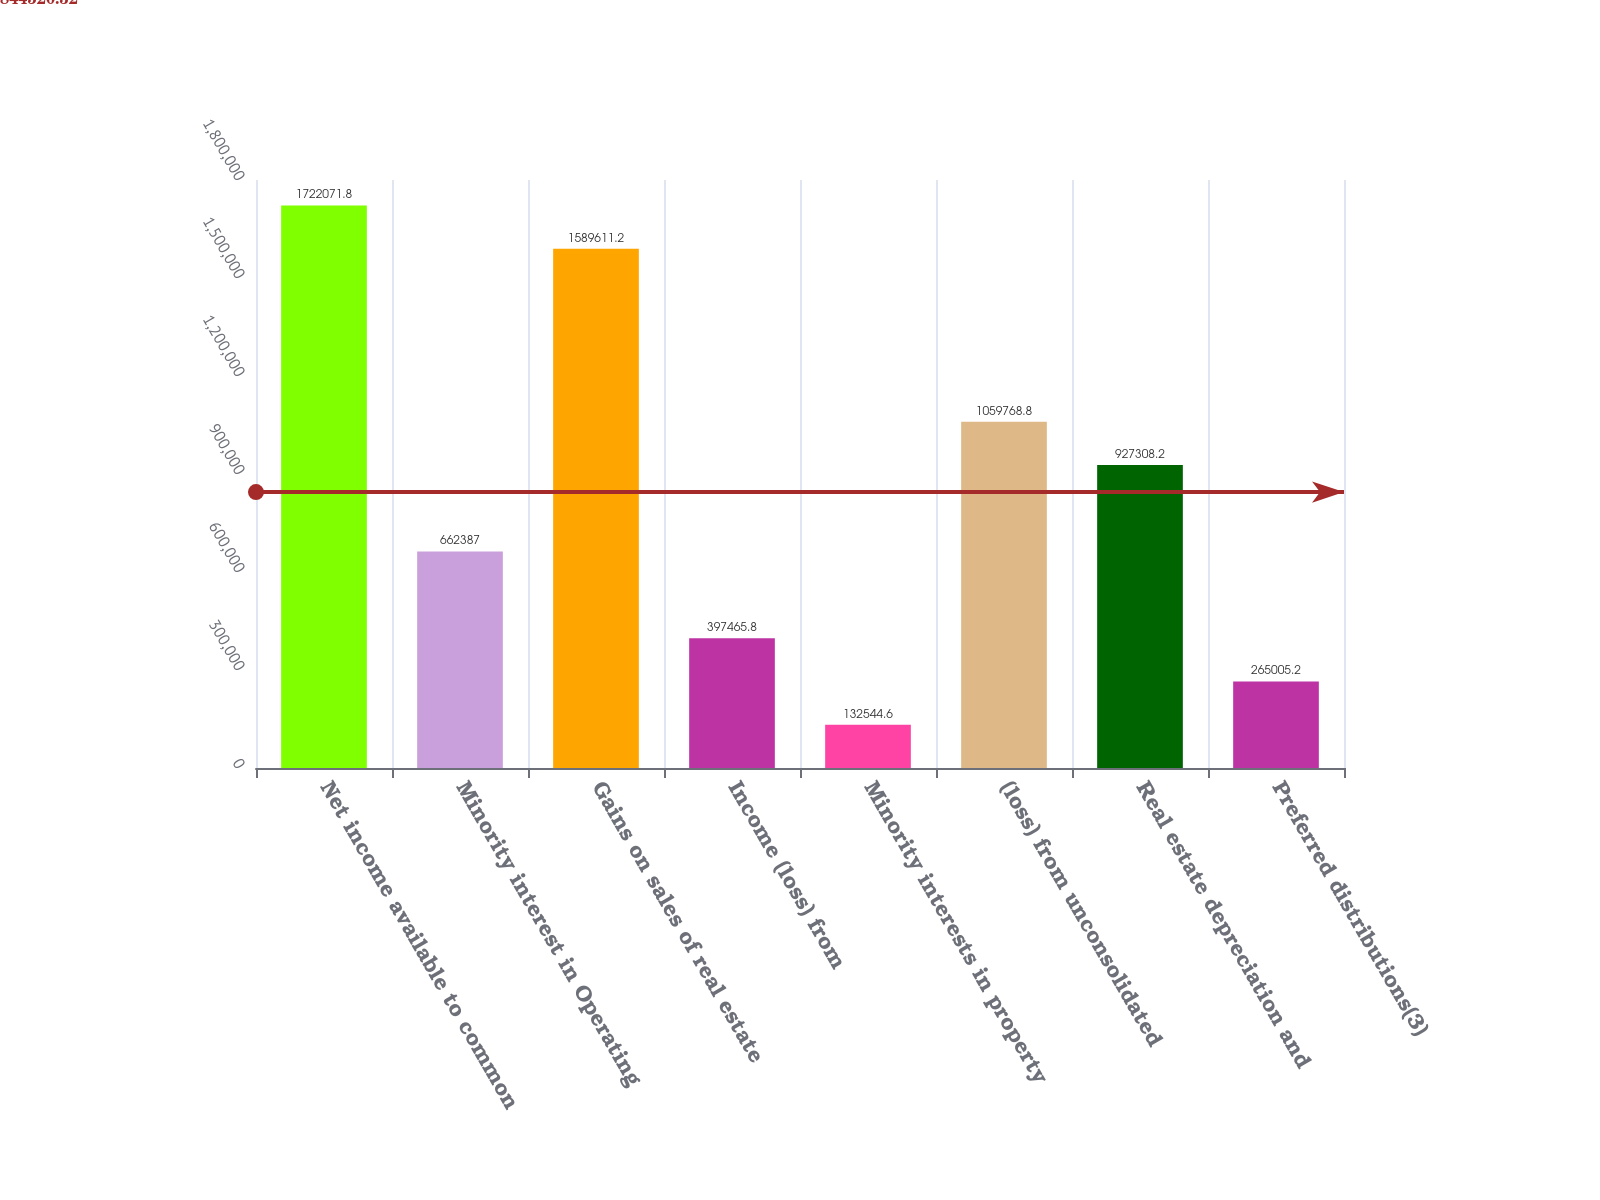Convert chart. <chart><loc_0><loc_0><loc_500><loc_500><bar_chart><fcel>Net income available to common<fcel>Minority interest in Operating<fcel>Gains on sales of real estate<fcel>Income (loss) from<fcel>Minority interests in property<fcel>(loss) from unconsolidated<fcel>Real estate depreciation and<fcel>Preferred distributions(3)<nl><fcel>1.72207e+06<fcel>662387<fcel>1.58961e+06<fcel>397466<fcel>132545<fcel>1.05977e+06<fcel>927308<fcel>265005<nl></chart> 